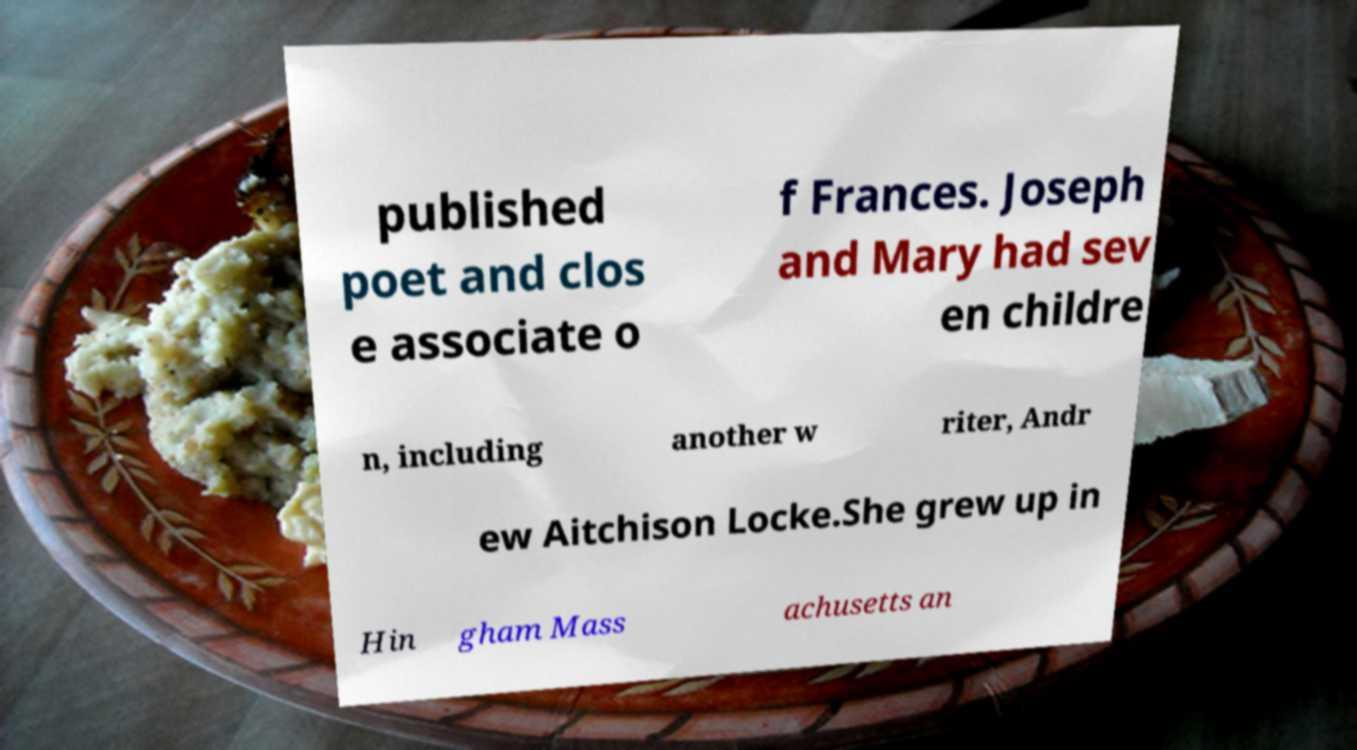Could you extract and type out the text from this image? published poet and clos e associate o f Frances. Joseph and Mary had sev en childre n, including another w riter, Andr ew Aitchison Locke.She grew up in Hin gham Mass achusetts an 